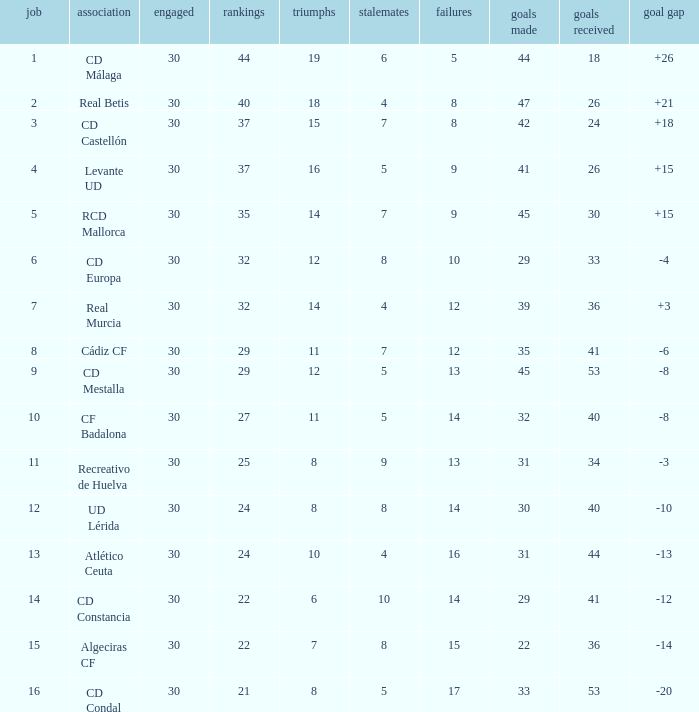Can you give me this table as a dict? {'header': ['job', 'association', 'engaged', 'rankings', 'triumphs', 'stalemates', 'failures', 'goals made', 'goals received', 'goal gap'], 'rows': [['1', 'CD Málaga', '30', '44', '19', '6', '5', '44', '18', '+26'], ['2', 'Real Betis', '30', '40', '18', '4', '8', '47', '26', '+21'], ['3', 'CD Castellón', '30', '37', '15', '7', '8', '42', '24', '+18'], ['4', 'Levante UD', '30', '37', '16', '5', '9', '41', '26', '+15'], ['5', 'RCD Mallorca', '30', '35', '14', '7', '9', '45', '30', '+15'], ['6', 'CD Europa', '30', '32', '12', '8', '10', '29', '33', '-4'], ['7', 'Real Murcia', '30', '32', '14', '4', '12', '39', '36', '+3'], ['8', 'Cádiz CF', '30', '29', '11', '7', '12', '35', '41', '-6'], ['9', 'CD Mestalla', '30', '29', '12', '5', '13', '45', '53', '-8'], ['10', 'CF Badalona', '30', '27', '11', '5', '14', '32', '40', '-8'], ['11', 'Recreativo de Huelva', '30', '25', '8', '9', '13', '31', '34', '-3'], ['12', 'UD Lérida', '30', '24', '8', '8', '14', '30', '40', '-10'], ['13', 'Atlético Ceuta', '30', '24', '10', '4', '16', '31', '44', '-13'], ['14', 'CD Constancia', '30', '22', '6', '10', '14', '29', '41', '-12'], ['15', 'Algeciras CF', '30', '22', '7', '8', '15', '22', '36', '-14'], ['16', 'CD Condal', '30', '21', '8', '5', '17', '33', '53', '-20']]} What is the losses when the goal difference is larger than 26? None. 